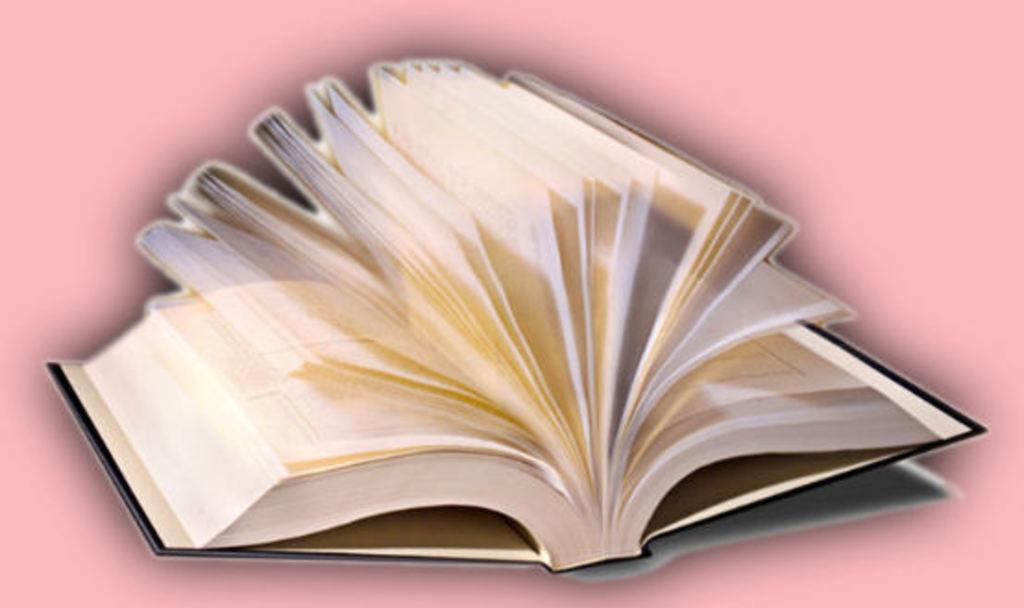What object can be seen in the picture? There is a book in the picture. What is the state of the book in the image? The book is opened. What color is the background of the image? The background color is pink. What sense can be seen in the picture? There is no sense visible in the picture; it features a book and a pink background. What type of spark is present in the image? There is no spark present in the image; it features a book and a pink background. 